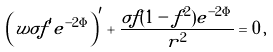<formula> <loc_0><loc_0><loc_500><loc_500>\left ( w \sigma f ^ { \prime } e ^ { - 2 \Phi } \right ) ^ { \prime } + \frac { \sigma f ( 1 - f ^ { 2 } ) e ^ { - 2 \Phi } } { r ^ { 2 } } = 0 \, ,</formula> 